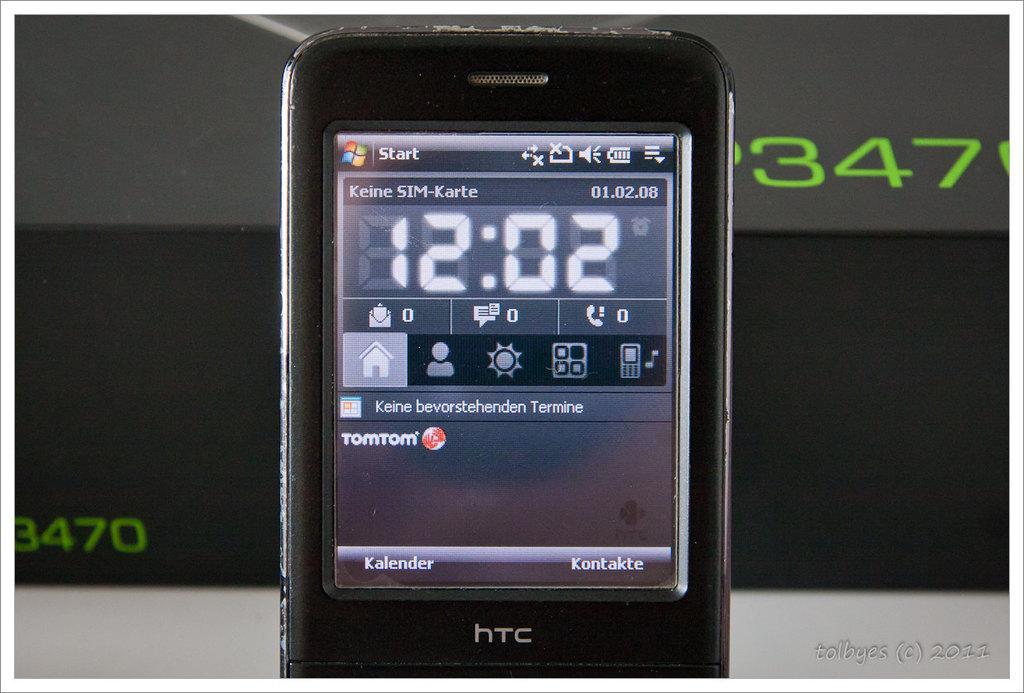Can you describe this image briefly? In this image we can see a mobile which is truncated. On the mobile screen we can see text and icons. In the background we can see some text on an object. At the bottom of the image we can see something is written on it. 